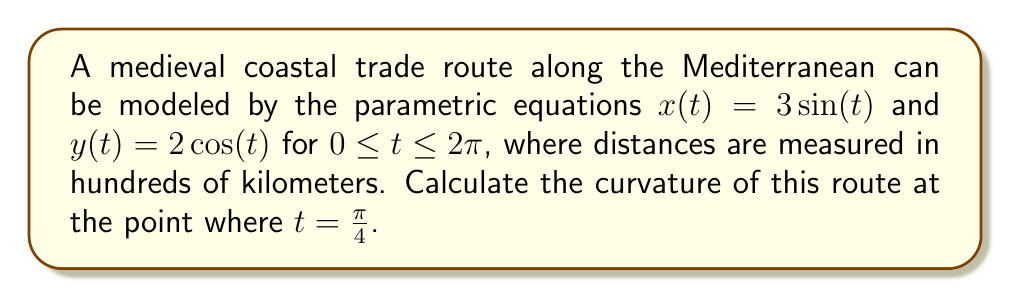Show me your answer to this math problem. To find the curvature of the parametric curve at a given point, we'll follow these steps:

1) The formula for curvature of a parametric curve is:

   $$\kappa = \frac{|x'y'' - y'x''|}{(x'^2 + y'^2)^{3/2}}$$

2) First, we need to find $x'$, $y'$, $x''$, and $y''$:
   
   $x' = 3\cos(t)$
   $y' = -2\sin(t)$
   $x'' = -3\sin(t)$
   $y'' = -2\cos(t)$

3) Now, let's evaluate these at $t = \frac{\pi}{4}$:
   
   $x'(\frac{\pi}{4}) = 3\cos(\frac{\pi}{4}) = \frac{3\sqrt{2}}{2}$
   $y'(\frac{\pi}{4}) = -2\sin(\frac{\pi}{4}) = -\sqrt{2}$
   $x''(\frac{\pi}{4}) = -3\sin(\frac{\pi}{4}) = -\frac{3\sqrt{2}}{2}$
   $y''(\frac{\pi}{4}) = -2\cos(\frac{\pi}{4}) = -\sqrt{2}$

4) Let's calculate the numerator of the curvature formula:
   
   $|x'y'' - y'x''| = |\frac{3\sqrt{2}}{2}(-\sqrt{2}) - (-\sqrt{2})(-\frac{3\sqrt{2}}{2})|$
                    $= |-3 - 3| = 6$

5) Now for the denominator:
   
   $(x'^2 + y'^2)^{3/2} = ((\frac{3\sqrt{2}}{2})^2 + (-\sqrt{2})^2)^{3/2}$
                        $= (\frac{9}{2} + 2)^{3/2} = (\frac{13}{2})^{3/2}$

6) Putting it all together:

   $$\kappa = \frac{6}{(\frac{13}{2})^{3/2}} = \frac{6}{(\frac{13}{2})^{3/2}} \cdot \frac{2^{3/2}}{2^{3/2}} = \frac{12\sqrt{2}}{13\sqrt{13}}$$

This curvature value represents how sharply the trade route bends at this point, which could be crucial information for medieval ship navigators.
Answer: $\frac{12\sqrt{2}}{13\sqrt{13}}$ per hundred kilometers 